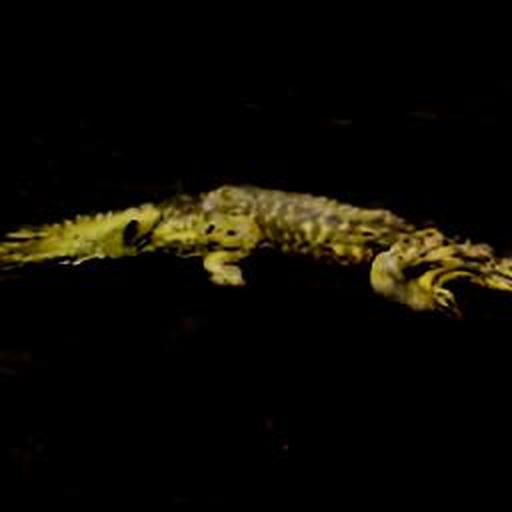How does the lighting in this photo affect your perception of the animal? The dim lighting and prominent shadows create an ominous impression of the animal, emphasizing its predatory nature. The darkness seems to envelop the creature, leaving parts of its form to the imagination and potentially evoking a sense of danger or mystery in the viewer. Could this possibly be used in a study on animal camouflage? Absolutely. This image illustrates how darkness and natural habitat can conceal an animal like a crocodile from view, even when it is in plain sight. It's a good representation of how these animals can blend with their environment, an essential aspect of their survival mechanism and a fascinating subject for biologists studying camouflage. 